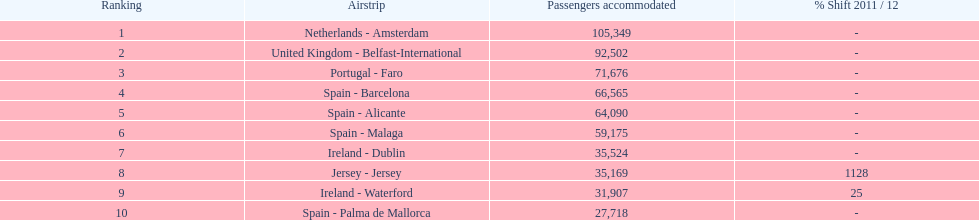How many airports are listed? 10. Parse the full table. {'header': ['Ranking', 'Airstrip', 'Passengers accommodated', '% Shift 2011 / 12'], 'rows': [['1', 'Netherlands - Amsterdam', '105,349', '-'], ['2', 'United Kingdom - Belfast-International', '92,502', '-'], ['3', 'Portugal - Faro', '71,676', '-'], ['4', 'Spain - Barcelona', '66,565', '-'], ['5', 'Spain - Alicante', '64,090', '-'], ['6', 'Spain - Malaga', '59,175', '-'], ['7', 'Ireland - Dublin', '35,524', '-'], ['8', 'Jersey - Jersey', '35,169', '1128'], ['9', 'Ireland - Waterford', '31,907', '25'], ['10', 'Spain - Palma de Mallorca', '27,718', '-']]} 